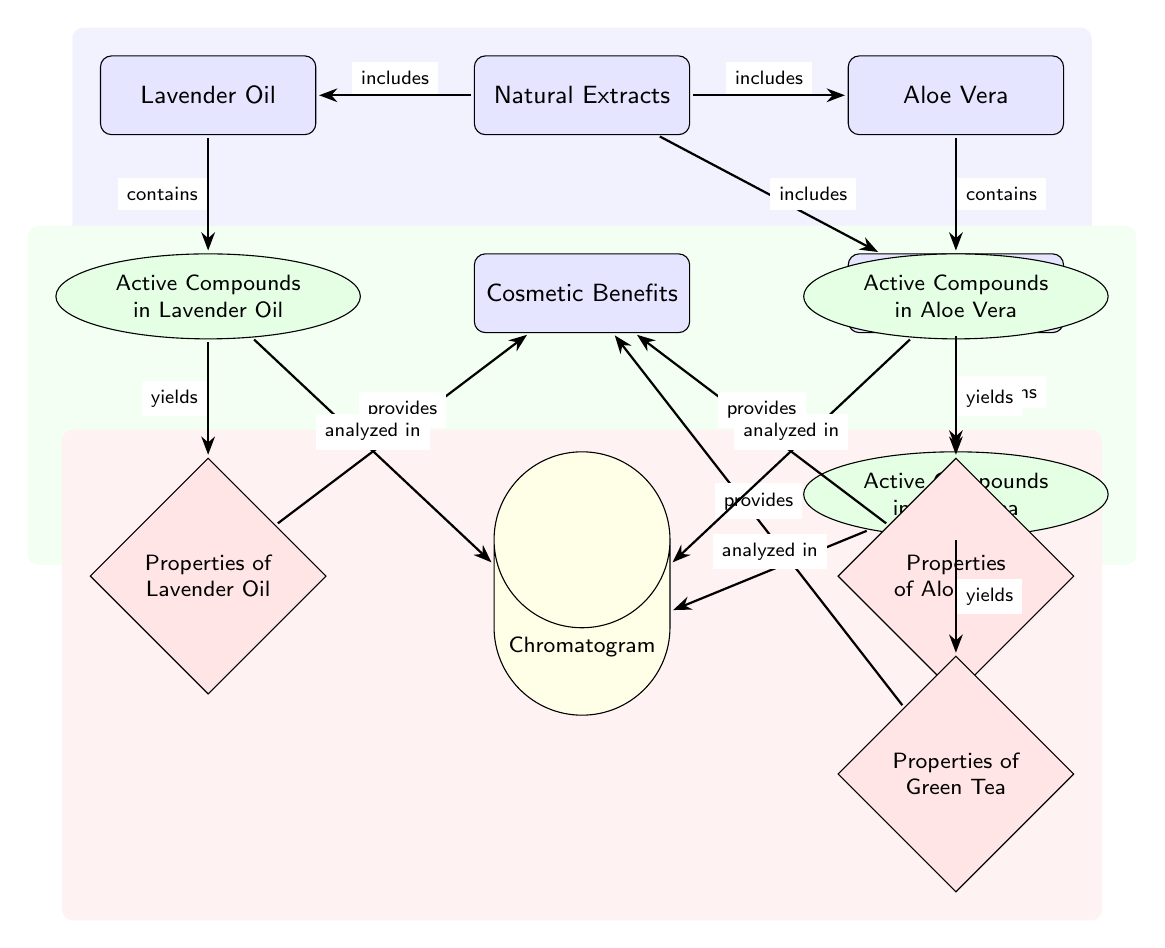What are the three natural extracts represented in the diagram? The diagram clearly lists Lavender Oil, Aloe Vera, and Green Tea as the three natural extracts.
Answer: Lavender Oil, Aloe Vera, Green Tea How many active compounds are associated with Aloe Vera? The diagram indicates that Aloe Vera is connected to one compound node labeled "Active Compounds in Aloe Vera," implying one active compound.
Answer: One What relationship exists between active compounds and cosmetic benefits? The diagram shows that active compounds yield properties, which in turn provide cosmetic benefits, depicting a flow of information from active compounds to cosmetic benefits.
Answer: Yields Which extract has the associated property of providing relaxation? The diagram includes Lavender Oil leading to properties that yield relaxation as a cosmetic benefit.
Answer: Lavender Oil What is the purpose of the chromatogram in the diagram? The chromatogram serves to analyze the active compounds from the various natural extracts, as indicated by the arrows going from each compound to the chromatogram node.
Answer: Analyzed in How do the properties of Green Tea influence cosmetic benefits? The properties derived from the active compounds in Green Tea provide cosmetic benefits, demonstrating the relationship between Green Tea's properties and its benefit outcome.
Answer: Provides What type of diagram is represented here, and what is its primary focus? The diagram is a Biomedical Diagram, focusing on the effectiveness of natural extracts used in cosmetics through the comparative analysis of their active compounds.
Answer: Biomedical Diagram How many edges are connecting natural extracts to their respective active compounds? The diagram displays three arrows connecting each natural extract to one active compound, culminating in a total of three edges.
Answer: Three 